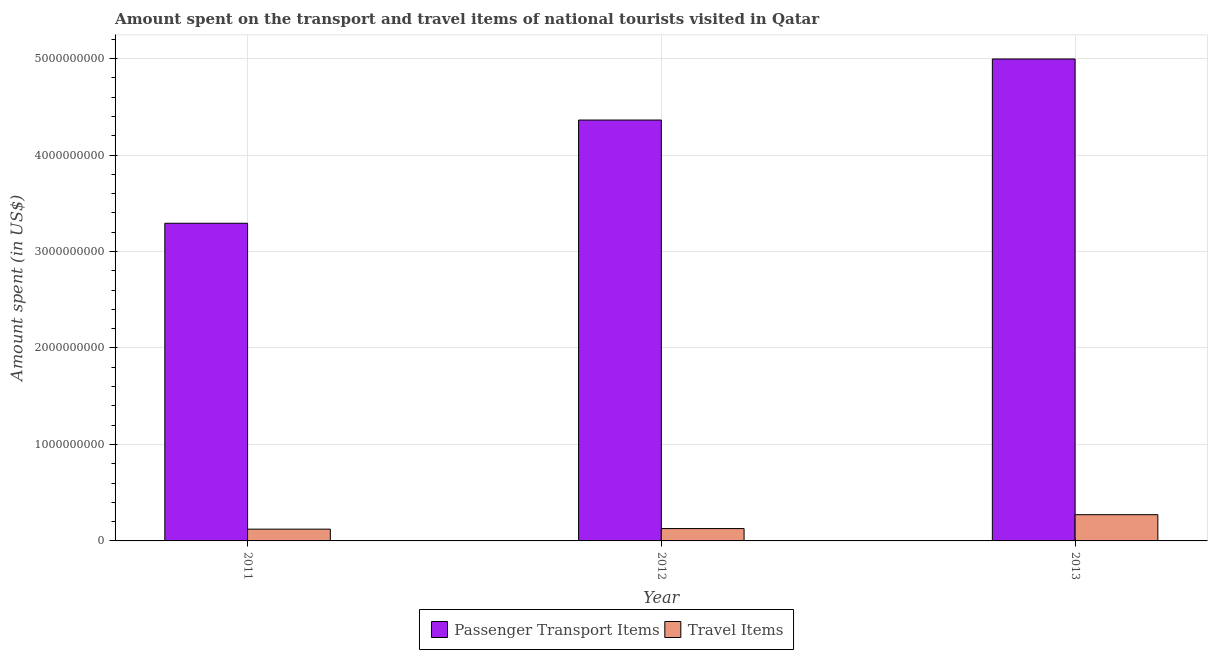How many groups of bars are there?
Provide a succinct answer. 3. Are the number of bars per tick equal to the number of legend labels?
Ensure brevity in your answer.  Yes. Are the number of bars on each tick of the X-axis equal?
Make the answer very short. Yes. How many bars are there on the 2nd tick from the right?
Make the answer very short. 2. What is the amount spent in travel items in 2012?
Provide a short and direct response. 1.28e+08. Across all years, what is the maximum amount spent on passenger transport items?
Provide a short and direct response. 5.00e+09. Across all years, what is the minimum amount spent on passenger transport items?
Your answer should be compact. 3.29e+09. In which year was the amount spent on passenger transport items maximum?
Your answer should be very brief. 2013. What is the total amount spent in travel items in the graph?
Your response must be concise. 5.22e+08. What is the difference between the amount spent on passenger transport items in 2011 and that in 2013?
Make the answer very short. -1.70e+09. What is the difference between the amount spent on passenger transport items in 2012 and the amount spent in travel items in 2011?
Ensure brevity in your answer.  1.07e+09. What is the average amount spent on passenger transport items per year?
Your answer should be very brief. 4.22e+09. In how many years, is the amount spent in travel items greater than 400000000 US$?
Keep it short and to the point. 0. What is the ratio of the amount spent in travel items in 2012 to that in 2013?
Provide a succinct answer. 0.47. Is the amount spent in travel items in 2011 less than that in 2013?
Your response must be concise. Yes. Is the difference between the amount spent in travel items in 2011 and 2012 greater than the difference between the amount spent on passenger transport items in 2011 and 2012?
Keep it short and to the point. No. What is the difference between the highest and the second highest amount spent on passenger transport items?
Provide a short and direct response. 6.33e+08. What is the difference between the highest and the lowest amount spent in travel items?
Make the answer very short. 1.50e+08. What does the 1st bar from the left in 2012 represents?
Make the answer very short. Passenger Transport Items. What does the 1st bar from the right in 2013 represents?
Offer a very short reply. Travel Items. What is the difference between two consecutive major ticks on the Y-axis?
Provide a succinct answer. 1.00e+09. Does the graph contain grids?
Give a very brief answer. Yes. How are the legend labels stacked?
Provide a short and direct response. Horizontal. What is the title of the graph?
Your response must be concise. Amount spent on the transport and travel items of national tourists visited in Qatar. What is the label or title of the Y-axis?
Provide a succinct answer. Amount spent (in US$). What is the Amount spent (in US$) in Passenger Transport Items in 2011?
Provide a short and direct response. 3.29e+09. What is the Amount spent (in US$) of Travel Items in 2011?
Your answer should be compact. 1.22e+08. What is the Amount spent (in US$) in Passenger Transport Items in 2012?
Offer a terse response. 4.36e+09. What is the Amount spent (in US$) in Travel Items in 2012?
Your response must be concise. 1.28e+08. What is the Amount spent (in US$) of Passenger Transport Items in 2013?
Offer a terse response. 5.00e+09. What is the Amount spent (in US$) of Travel Items in 2013?
Your response must be concise. 2.72e+08. Across all years, what is the maximum Amount spent (in US$) in Passenger Transport Items?
Your answer should be compact. 5.00e+09. Across all years, what is the maximum Amount spent (in US$) of Travel Items?
Provide a short and direct response. 2.72e+08. Across all years, what is the minimum Amount spent (in US$) of Passenger Transport Items?
Make the answer very short. 3.29e+09. Across all years, what is the minimum Amount spent (in US$) of Travel Items?
Your answer should be compact. 1.22e+08. What is the total Amount spent (in US$) of Passenger Transport Items in the graph?
Your answer should be very brief. 1.27e+1. What is the total Amount spent (in US$) in Travel Items in the graph?
Your answer should be very brief. 5.22e+08. What is the difference between the Amount spent (in US$) in Passenger Transport Items in 2011 and that in 2012?
Offer a terse response. -1.07e+09. What is the difference between the Amount spent (in US$) in Travel Items in 2011 and that in 2012?
Your answer should be compact. -6.00e+06. What is the difference between the Amount spent (in US$) in Passenger Transport Items in 2011 and that in 2013?
Offer a terse response. -1.70e+09. What is the difference between the Amount spent (in US$) of Travel Items in 2011 and that in 2013?
Provide a short and direct response. -1.50e+08. What is the difference between the Amount spent (in US$) in Passenger Transport Items in 2012 and that in 2013?
Ensure brevity in your answer.  -6.33e+08. What is the difference between the Amount spent (in US$) of Travel Items in 2012 and that in 2013?
Your answer should be very brief. -1.44e+08. What is the difference between the Amount spent (in US$) of Passenger Transport Items in 2011 and the Amount spent (in US$) of Travel Items in 2012?
Your answer should be compact. 3.16e+09. What is the difference between the Amount spent (in US$) in Passenger Transport Items in 2011 and the Amount spent (in US$) in Travel Items in 2013?
Your answer should be compact. 3.02e+09. What is the difference between the Amount spent (in US$) in Passenger Transport Items in 2012 and the Amount spent (in US$) in Travel Items in 2013?
Make the answer very short. 4.09e+09. What is the average Amount spent (in US$) of Passenger Transport Items per year?
Provide a short and direct response. 4.22e+09. What is the average Amount spent (in US$) of Travel Items per year?
Ensure brevity in your answer.  1.74e+08. In the year 2011, what is the difference between the Amount spent (in US$) in Passenger Transport Items and Amount spent (in US$) in Travel Items?
Your answer should be compact. 3.17e+09. In the year 2012, what is the difference between the Amount spent (in US$) in Passenger Transport Items and Amount spent (in US$) in Travel Items?
Your response must be concise. 4.24e+09. In the year 2013, what is the difference between the Amount spent (in US$) in Passenger Transport Items and Amount spent (in US$) in Travel Items?
Make the answer very short. 4.72e+09. What is the ratio of the Amount spent (in US$) of Passenger Transport Items in 2011 to that in 2012?
Keep it short and to the point. 0.75. What is the ratio of the Amount spent (in US$) in Travel Items in 2011 to that in 2012?
Give a very brief answer. 0.95. What is the ratio of the Amount spent (in US$) of Passenger Transport Items in 2011 to that in 2013?
Your answer should be very brief. 0.66. What is the ratio of the Amount spent (in US$) in Travel Items in 2011 to that in 2013?
Keep it short and to the point. 0.45. What is the ratio of the Amount spent (in US$) of Passenger Transport Items in 2012 to that in 2013?
Make the answer very short. 0.87. What is the ratio of the Amount spent (in US$) in Travel Items in 2012 to that in 2013?
Provide a short and direct response. 0.47. What is the difference between the highest and the second highest Amount spent (in US$) of Passenger Transport Items?
Ensure brevity in your answer.  6.33e+08. What is the difference between the highest and the second highest Amount spent (in US$) in Travel Items?
Offer a terse response. 1.44e+08. What is the difference between the highest and the lowest Amount spent (in US$) of Passenger Transport Items?
Provide a succinct answer. 1.70e+09. What is the difference between the highest and the lowest Amount spent (in US$) in Travel Items?
Provide a short and direct response. 1.50e+08. 